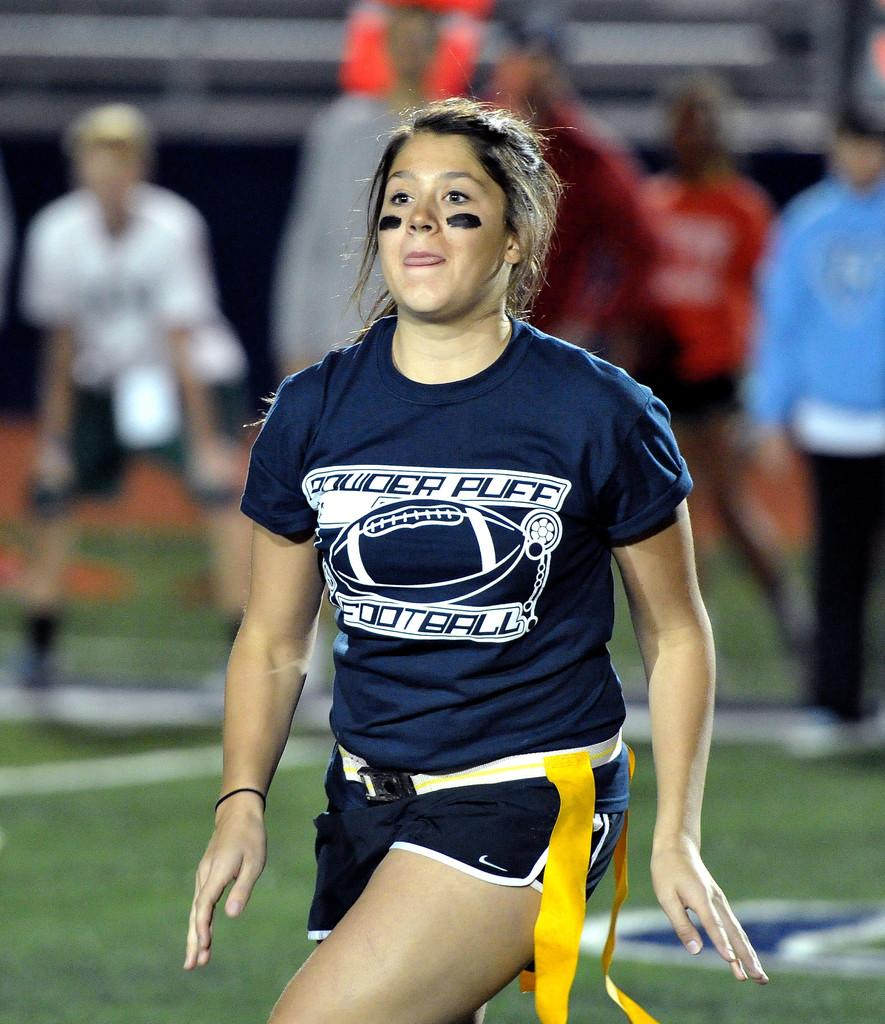<image>
Write a terse but informative summary of the picture. A woman sports player with the words Powder Puff on her top 